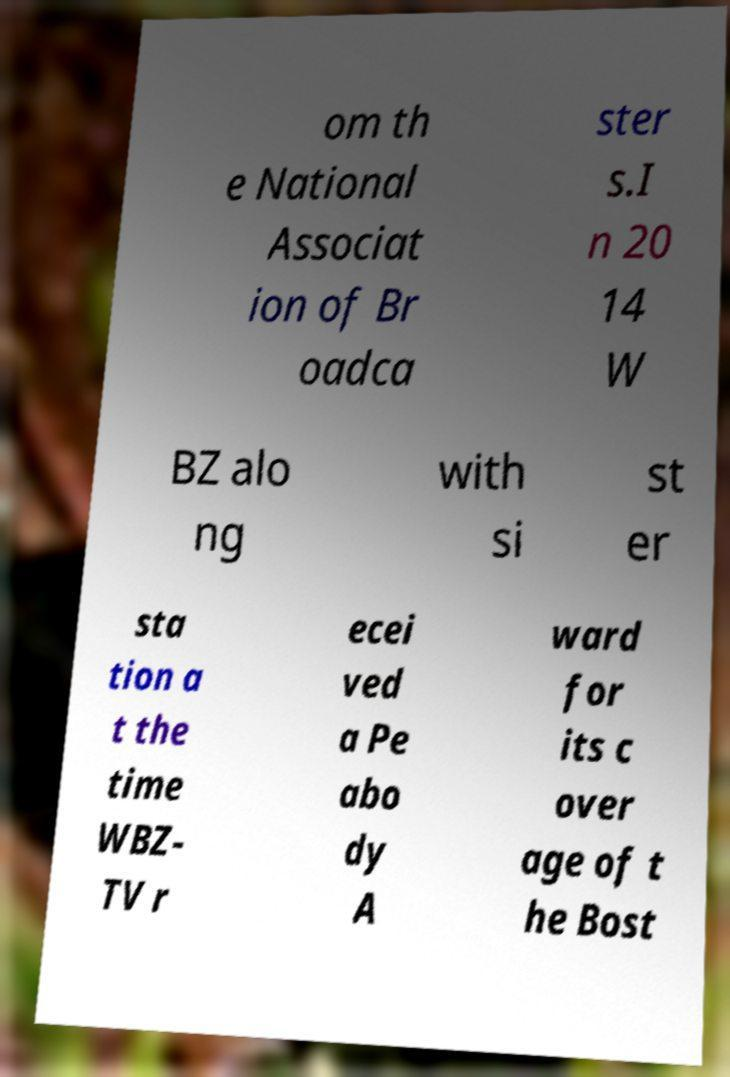Can you read and provide the text displayed in the image?This photo seems to have some interesting text. Can you extract and type it out for me? om th e National Associat ion of Br oadca ster s.I n 20 14 W BZ alo ng with si st er sta tion a t the time WBZ- TV r ecei ved a Pe abo dy A ward for its c over age of t he Bost 